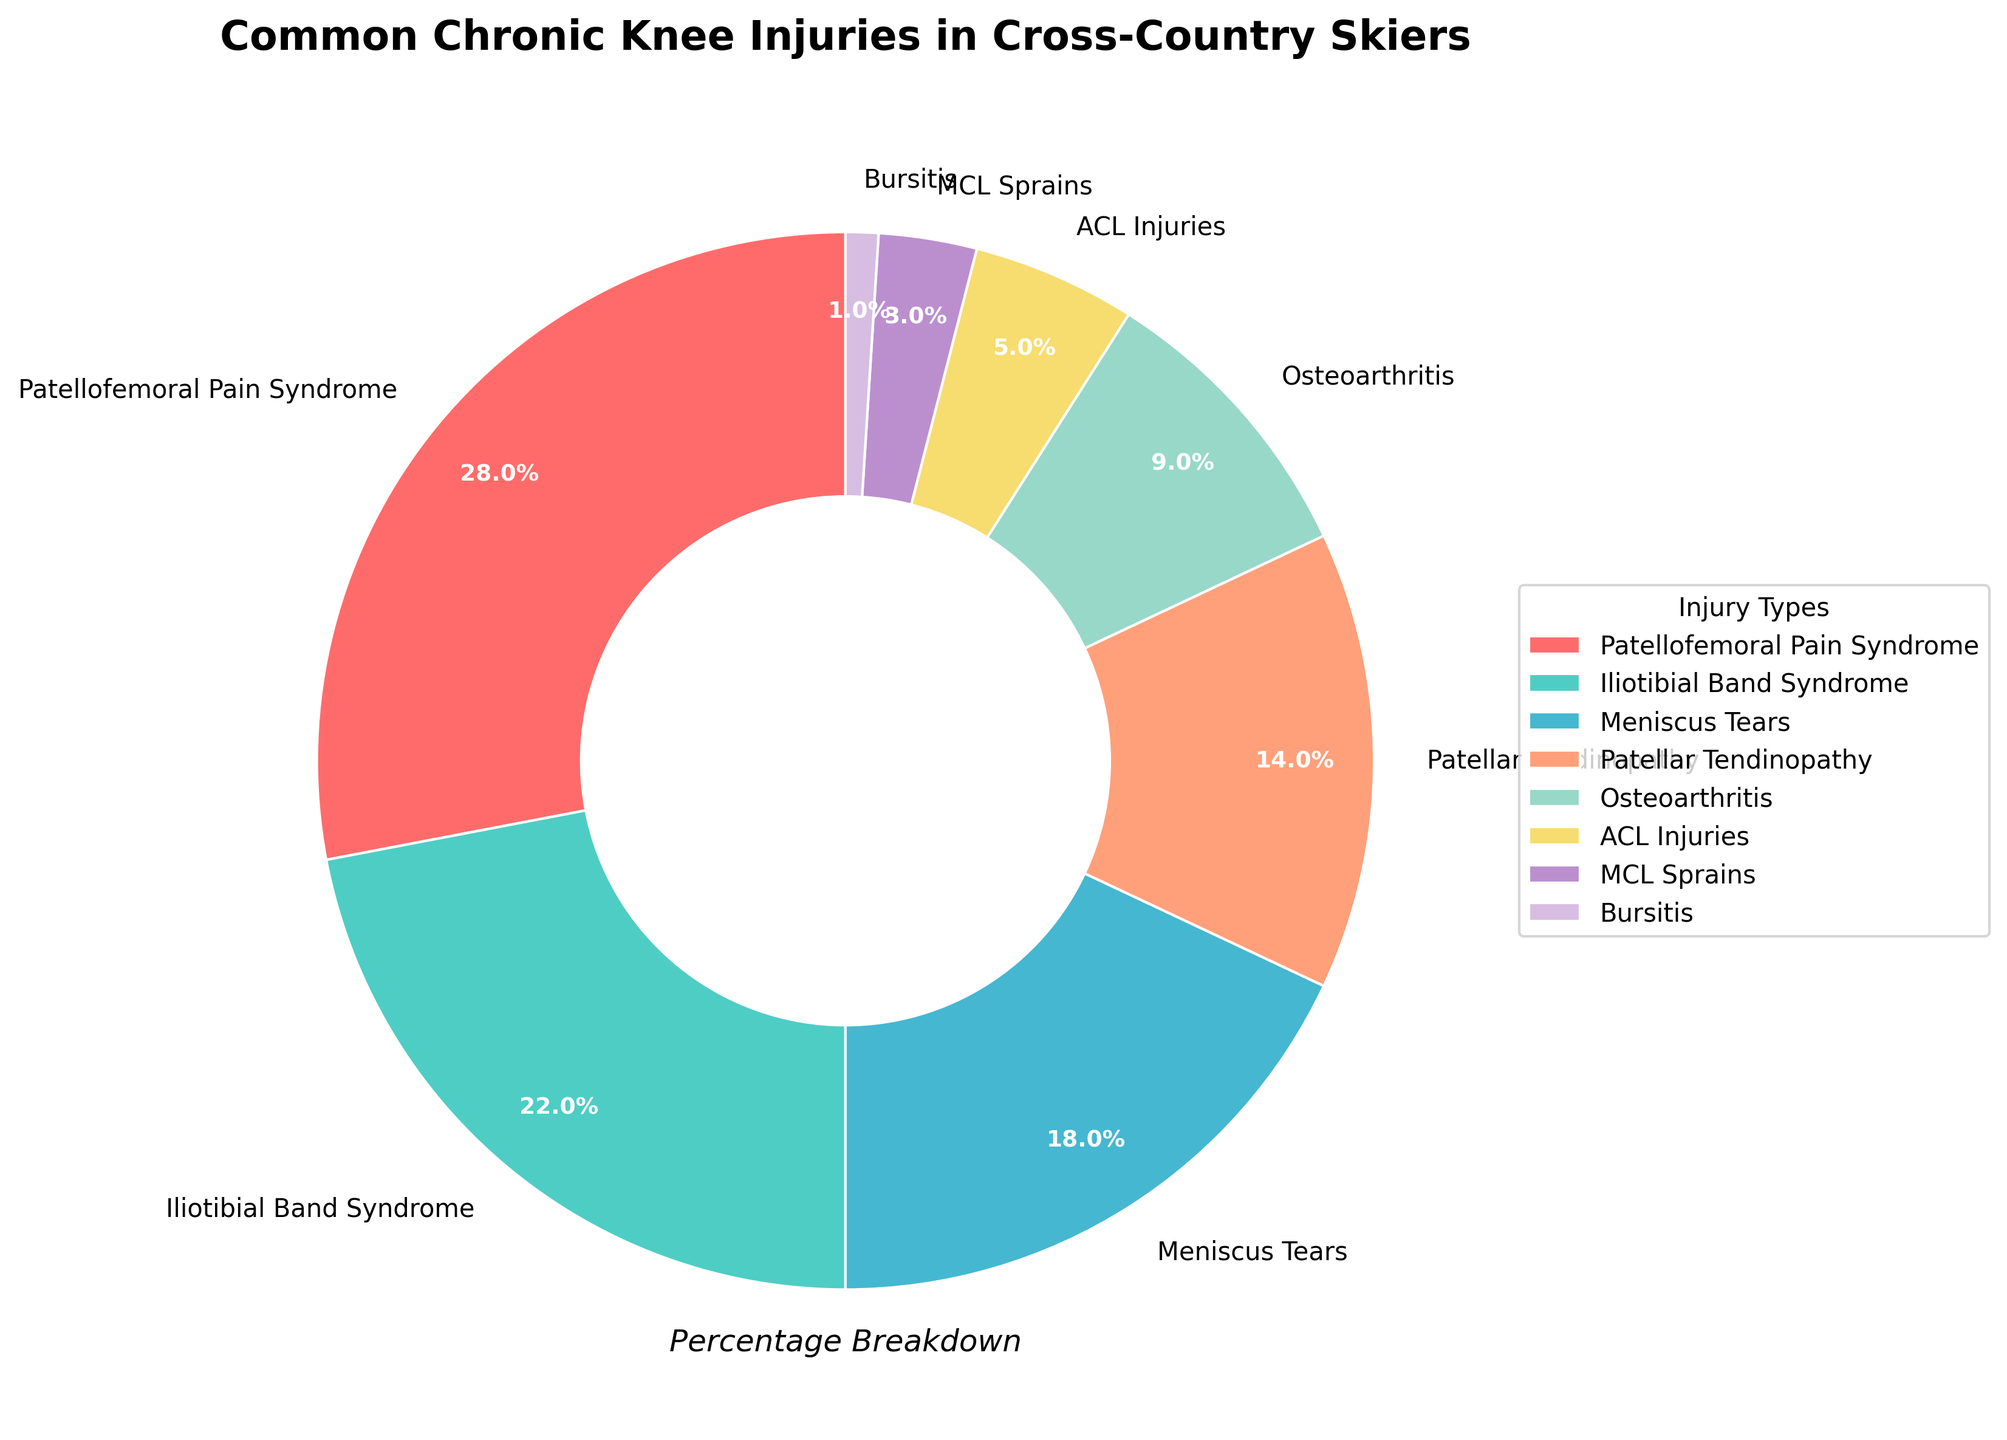what is the most common chronic knee injury among cross-country skiers? The figure shows the percentages of different chronic knee injuries, and the sector with the highest percentage represents the most common injury, which is Patellofemoral Pain Syndrome at 28%.
Answer: Patellofemoral Pain Syndrome Which injury types together make up over half of the total percentage? Adding the percentages of the top injuries, Patellofemoral Pain Syndrome (28%) and Iliotibial Band Syndrome (22%), we get 28% + 22% = 50%, which already constitutes half. Including Meniscus Tears (18%) reaches 68%. Therefore, these three injury types together make up over half of the total percentage.
Answer: Patellofemoral Pain Syndrome, Iliotibial Band Syndrome, Meniscus Tears How does the percentage of Patellar Tendinopathy compare to that of Osteoarthritis? The figure shows Patellar Tendinopathy at 14% and Osteoarthritis at 9%. To compare, we can subtract the percentage of Osteoarthritis from Patellar Tendinopathy: 14% - 9% = 5%. Patellar Tendinopathy is 5% higher than Osteoarthritis.
Answer: 5% higher What is the total percentage of ACL Injuries and MCL Sprains? The chart shows ACL Injuries at 5% and MCL Sprains at 3%. Adding these percentages together, 5% + 3% = 8%. The total percentage of ACL Injuries and MCL Sprains is 8%.
Answer: 8% Which injury type makes up the smallest percentage, and what is its value? The smallest sector in the pie chart represents Bursitis, which is listed at 1%.
Answer: Bursitis, 1% By how much does the percentage of Iliotibial Band Syndrome differ from that of Meniscus Tears? The figure shows Iliotibial Band Syndrome at 22% and Meniscus Tears at 18%. Subtracting the percentage of Meniscus Tears from Iliotibial Band Syndrome, 22% - 18% = 4%. The percentage difference is 4%.
Answer: 4% What is the combined percentage of all injuries that constitute less than 10% each? The injuries with less than 10% each are Osteoarthritis (9%), ACL Injuries (5%), MCL Sprains (3%), and Bursitis (1%). Adding these percentages together: 9% + 5% + 3% + 1% = 18%. The combined percentage is 18%.
Answer: 18% If a skier has either Iliotibial Band Syndrome or Patellofemoral Pain Syndrome, what is the probability that they have Patellofemoral Pain Syndrome? The percentage for Patellofemoral Pain Syndrome is 28% and for Iliotibial Band Syndrome is 22%. Adding these gives the total probability base (28% + 22% = 50%). The probability of having Patellofemoral Pain Syndrome out of this base is the ratio of 28% to 50%, calculated as (28 / 50) * 100% = 56%.
Answer: 56% Which injury is more prevalent: Patellar Tendinopathy or Meniscus Tears? The pie chart shows Patellar Tendinopathy at 14% and Meniscus Tears at 18%. Comparing these, Meniscus Tears have a higher percentage than Patellar Tendinopathy.
Answer: Meniscus Tears 